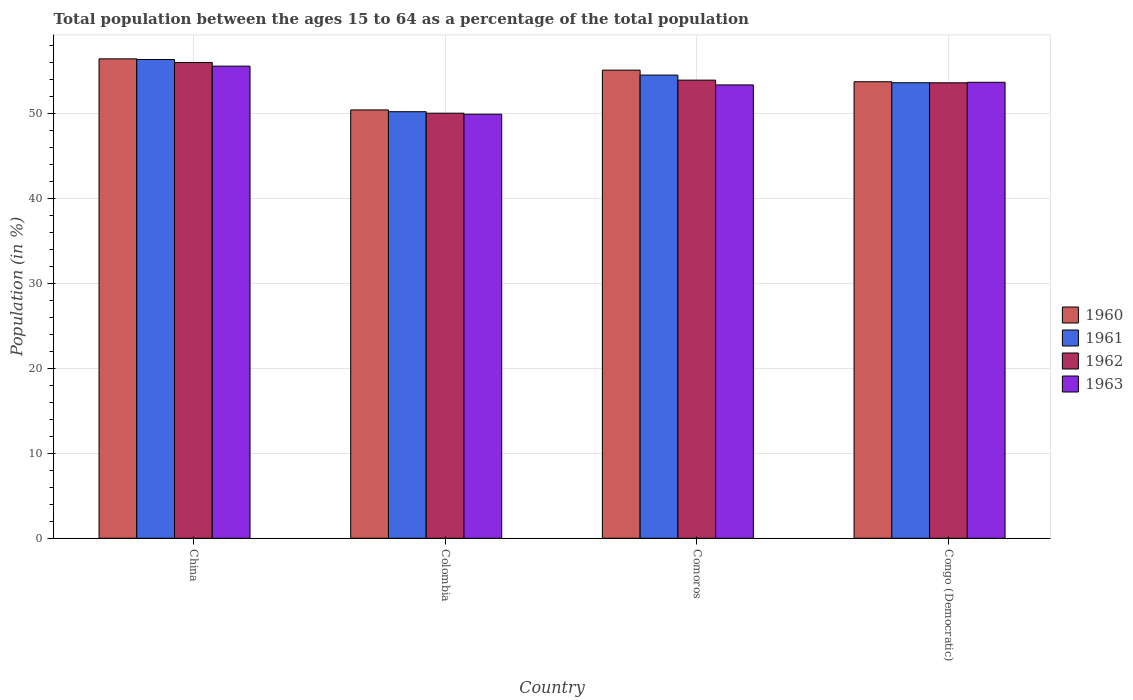How many groups of bars are there?
Your response must be concise. 4. Are the number of bars per tick equal to the number of legend labels?
Ensure brevity in your answer.  Yes. Are the number of bars on each tick of the X-axis equal?
Give a very brief answer. Yes. How many bars are there on the 1st tick from the right?
Make the answer very short. 4. What is the label of the 4th group of bars from the left?
Offer a very short reply. Congo (Democratic). What is the percentage of the population ages 15 to 64 in 1963 in Comoros?
Offer a very short reply. 53.33. Across all countries, what is the maximum percentage of the population ages 15 to 64 in 1960?
Offer a terse response. 56.39. Across all countries, what is the minimum percentage of the population ages 15 to 64 in 1962?
Ensure brevity in your answer.  50. In which country was the percentage of the population ages 15 to 64 in 1962 minimum?
Offer a terse response. Colombia. What is the total percentage of the population ages 15 to 64 in 1962 in the graph?
Your answer should be very brief. 213.43. What is the difference between the percentage of the population ages 15 to 64 in 1962 in Colombia and that in Congo (Democratic)?
Ensure brevity in your answer.  -3.58. What is the difference between the percentage of the population ages 15 to 64 in 1960 in China and the percentage of the population ages 15 to 64 in 1962 in Congo (Democratic)?
Give a very brief answer. 2.82. What is the average percentage of the population ages 15 to 64 in 1963 per country?
Your answer should be compact. 53.1. What is the difference between the percentage of the population ages 15 to 64 of/in 1962 and percentage of the population ages 15 to 64 of/in 1963 in Comoros?
Keep it short and to the point. 0.56. What is the ratio of the percentage of the population ages 15 to 64 in 1962 in China to that in Comoros?
Provide a succinct answer. 1.04. What is the difference between the highest and the second highest percentage of the population ages 15 to 64 in 1963?
Ensure brevity in your answer.  -0.31. What is the difference between the highest and the lowest percentage of the population ages 15 to 64 in 1962?
Your answer should be very brief. 5.96. What does the 1st bar from the left in Comoros represents?
Offer a very short reply. 1960. Is it the case that in every country, the sum of the percentage of the population ages 15 to 64 in 1962 and percentage of the population ages 15 to 64 in 1963 is greater than the percentage of the population ages 15 to 64 in 1960?
Provide a succinct answer. Yes. How many bars are there?
Your response must be concise. 16. How many countries are there in the graph?
Give a very brief answer. 4. What is the difference between two consecutive major ticks on the Y-axis?
Your answer should be very brief. 10. Are the values on the major ticks of Y-axis written in scientific E-notation?
Make the answer very short. No. Does the graph contain grids?
Provide a succinct answer. Yes. How many legend labels are there?
Make the answer very short. 4. What is the title of the graph?
Keep it short and to the point. Total population between the ages 15 to 64 as a percentage of the total population. Does "2009" appear as one of the legend labels in the graph?
Your response must be concise. No. What is the label or title of the Y-axis?
Give a very brief answer. Population (in %). What is the Population (in %) of 1960 in China?
Give a very brief answer. 56.39. What is the Population (in %) in 1961 in China?
Keep it short and to the point. 56.32. What is the Population (in %) in 1962 in China?
Give a very brief answer. 55.96. What is the Population (in %) of 1963 in China?
Provide a short and direct response. 55.54. What is the Population (in %) in 1960 in Colombia?
Your answer should be compact. 50.39. What is the Population (in %) of 1961 in Colombia?
Your response must be concise. 50.18. What is the Population (in %) of 1962 in Colombia?
Give a very brief answer. 50. What is the Population (in %) in 1963 in Colombia?
Ensure brevity in your answer.  49.88. What is the Population (in %) in 1960 in Comoros?
Provide a succinct answer. 55.07. What is the Population (in %) of 1961 in Comoros?
Your answer should be very brief. 54.48. What is the Population (in %) in 1962 in Comoros?
Ensure brevity in your answer.  53.89. What is the Population (in %) of 1963 in Comoros?
Make the answer very short. 53.33. What is the Population (in %) of 1960 in Congo (Democratic)?
Provide a succinct answer. 53.7. What is the Population (in %) of 1961 in Congo (Democratic)?
Your answer should be very brief. 53.59. What is the Population (in %) in 1962 in Congo (Democratic)?
Provide a short and direct response. 53.58. What is the Population (in %) in 1963 in Congo (Democratic)?
Your answer should be compact. 53.64. Across all countries, what is the maximum Population (in %) in 1960?
Provide a short and direct response. 56.39. Across all countries, what is the maximum Population (in %) in 1961?
Provide a short and direct response. 56.32. Across all countries, what is the maximum Population (in %) in 1962?
Provide a succinct answer. 55.96. Across all countries, what is the maximum Population (in %) of 1963?
Make the answer very short. 55.54. Across all countries, what is the minimum Population (in %) of 1960?
Ensure brevity in your answer.  50.39. Across all countries, what is the minimum Population (in %) of 1961?
Give a very brief answer. 50.18. Across all countries, what is the minimum Population (in %) of 1962?
Make the answer very short. 50. Across all countries, what is the minimum Population (in %) in 1963?
Give a very brief answer. 49.88. What is the total Population (in %) of 1960 in the graph?
Offer a very short reply. 215.55. What is the total Population (in %) of 1961 in the graph?
Give a very brief answer. 214.56. What is the total Population (in %) of 1962 in the graph?
Your answer should be very brief. 213.43. What is the total Population (in %) in 1963 in the graph?
Your answer should be compact. 212.38. What is the difference between the Population (in %) in 1960 in China and that in Colombia?
Your response must be concise. 6.01. What is the difference between the Population (in %) in 1961 in China and that in Colombia?
Your response must be concise. 6.14. What is the difference between the Population (in %) in 1962 in China and that in Colombia?
Ensure brevity in your answer.  5.96. What is the difference between the Population (in %) of 1963 in China and that in Colombia?
Your answer should be compact. 5.65. What is the difference between the Population (in %) in 1960 in China and that in Comoros?
Offer a terse response. 1.33. What is the difference between the Population (in %) of 1961 in China and that in Comoros?
Your answer should be very brief. 1.83. What is the difference between the Population (in %) in 1962 in China and that in Comoros?
Make the answer very short. 2.07. What is the difference between the Population (in %) of 1963 in China and that in Comoros?
Provide a short and direct response. 2.21. What is the difference between the Population (in %) of 1960 in China and that in Congo (Democratic)?
Keep it short and to the point. 2.69. What is the difference between the Population (in %) in 1961 in China and that in Congo (Democratic)?
Make the answer very short. 2.73. What is the difference between the Population (in %) in 1962 in China and that in Congo (Democratic)?
Your answer should be compact. 2.38. What is the difference between the Population (in %) of 1963 in China and that in Congo (Democratic)?
Offer a very short reply. 1.9. What is the difference between the Population (in %) of 1960 in Colombia and that in Comoros?
Offer a terse response. -4.68. What is the difference between the Population (in %) of 1961 in Colombia and that in Comoros?
Offer a terse response. -4.31. What is the difference between the Population (in %) of 1962 in Colombia and that in Comoros?
Your answer should be compact. -3.89. What is the difference between the Population (in %) of 1963 in Colombia and that in Comoros?
Provide a succinct answer. -3.45. What is the difference between the Population (in %) of 1960 in Colombia and that in Congo (Democratic)?
Your answer should be compact. -3.32. What is the difference between the Population (in %) of 1961 in Colombia and that in Congo (Democratic)?
Keep it short and to the point. -3.41. What is the difference between the Population (in %) in 1962 in Colombia and that in Congo (Democratic)?
Give a very brief answer. -3.58. What is the difference between the Population (in %) in 1963 in Colombia and that in Congo (Democratic)?
Ensure brevity in your answer.  -3.76. What is the difference between the Population (in %) of 1960 in Comoros and that in Congo (Democratic)?
Provide a short and direct response. 1.36. What is the difference between the Population (in %) in 1961 in Comoros and that in Congo (Democratic)?
Provide a succinct answer. 0.9. What is the difference between the Population (in %) in 1962 in Comoros and that in Congo (Democratic)?
Provide a short and direct response. 0.31. What is the difference between the Population (in %) in 1963 in Comoros and that in Congo (Democratic)?
Keep it short and to the point. -0.31. What is the difference between the Population (in %) of 1960 in China and the Population (in %) of 1961 in Colombia?
Ensure brevity in your answer.  6.22. What is the difference between the Population (in %) in 1960 in China and the Population (in %) in 1962 in Colombia?
Your answer should be compact. 6.39. What is the difference between the Population (in %) in 1960 in China and the Population (in %) in 1963 in Colombia?
Keep it short and to the point. 6.51. What is the difference between the Population (in %) of 1961 in China and the Population (in %) of 1962 in Colombia?
Your response must be concise. 6.31. What is the difference between the Population (in %) of 1961 in China and the Population (in %) of 1963 in Colombia?
Ensure brevity in your answer.  6.44. What is the difference between the Population (in %) in 1962 in China and the Population (in %) in 1963 in Colombia?
Make the answer very short. 6.08. What is the difference between the Population (in %) of 1960 in China and the Population (in %) of 1961 in Comoros?
Make the answer very short. 1.91. What is the difference between the Population (in %) in 1960 in China and the Population (in %) in 1962 in Comoros?
Keep it short and to the point. 2.5. What is the difference between the Population (in %) of 1960 in China and the Population (in %) of 1963 in Comoros?
Give a very brief answer. 3.07. What is the difference between the Population (in %) of 1961 in China and the Population (in %) of 1962 in Comoros?
Offer a very short reply. 2.43. What is the difference between the Population (in %) of 1961 in China and the Population (in %) of 1963 in Comoros?
Provide a short and direct response. 2.99. What is the difference between the Population (in %) in 1962 in China and the Population (in %) in 1963 in Comoros?
Offer a terse response. 2.63. What is the difference between the Population (in %) of 1960 in China and the Population (in %) of 1961 in Congo (Democratic)?
Provide a succinct answer. 2.81. What is the difference between the Population (in %) in 1960 in China and the Population (in %) in 1962 in Congo (Democratic)?
Your answer should be very brief. 2.82. What is the difference between the Population (in %) in 1960 in China and the Population (in %) in 1963 in Congo (Democratic)?
Your answer should be very brief. 2.76. What is the difference between the Population (in %) of 1961 in China and the Population (in %) of 1962 in Congo (Democratic)?
Make the answer very short. 2.74. What is the difference between the Population (in %) of 1961 in China and the Population (in %) of 1963 in Congo (Democratic)?
Keep it short and to the point. 2.68. What is the difference between the Population (in %) of 1962 in China and the Population (in %) of 1963 in Congo (Democratic)?
Your response must be concise. 2.32. What is the difference between the Population (in %) of 1960 in Colombia and the Population (in %) of 1961 in Comoros?
Make the answer very short. -4.1. What is the difference between the Population (in %) of 1960 in Colombia and the Population (in %) of 1962 in Comoros?
Ensure brevity in your answer.  -3.5. What is the difference between the Population (in %) of 1960 in Colombia and the Population (in %) of 1963 in Comoros?
Offer a very short reply. -2.94. What is the difference between the Population (in %) in 1961 in Colombia and the Population (in %) in 1962 in Comoros?
Offer a terse response. -3.71. What is the difference between the Population (in %) of 1961 in Colombia and the Population (in %) of 1963 in Comoros?
Give a very brief answer. -3.15. What is the difference between the Population (in %) in 1962 in Colombia and the Population (in %) in 1963 in Comoros?
Provide a succinct answer. -3.33. What is the difference between the Population (in %) of 1960 in Colombia and the Population (in %) of 1961 in Congo (Democratic)?
Make the answer very short. -3.2. What is the difference between the Population (in %) in 1960 in Colombia and the Population (in %) in 1962 in Congo (Democratic)?
Your response must be concise. -3.19. What is the difference between the Population (in %) in 1960 in Colombia and the Population (in %) in 1963 in Congo (Democratic)?
Provide a short and direct response. -3.25. What is the difference between the Population (in %) of 1961 in Colombia and the Population (in %) of 1962 in Congo (Democratic)?
Give a very brief answer. -3.4. What is the difference between the Population (in %) of 1961 in Colombia and the Population (in %) of 1963 in Congo (Democratic)?
Offer a terse response. -3.46. What is the difference between the Population (in %) in 1962 in Colombia and the Population (in %) in 1963 in Congo (Democratic)?
Your answer should be very brief. -3.63. What is the difference between the Population (in %) in 1960 in Comoros and the Population (in %) in 1961 in Congo (Democratic)?
Provide a short and direct response. 1.48. What is the difference between the Population (in %) of 1960 in Comoros and the Population (in %) of 1962 in Congo (Democratic)?
Provide a succinct answer. 1.49. What is the difference between the Population (in %) in 1960 in Comoros and the Population (in %) in 1963 in Congo (Democratic)?
Offer a terse response. 1.43. What is the difference between the Population (in %) of 1961 in Comoros and the Population (in %) of 1962 in Congo (Democratic)?
Offer a very short reply. 0.91. What is the difference between the Population (in %) of 1961 in Comoros and the Population (in %) of 1963 in Congo (Democratic)?
Provide a succinct answer. 0.85. What is the difference between the Population (in %) in 1962 in Comoros and the Population (in %) in 1963 in Congo (Democratic)?
Your response must be concise. 0.25. What is the average Population (in %) of 1960 per country?
Your answer should be compact. 53.89. What is the average Population (in %) of 1961 per country?
Keep it short and to the point. 53.64. What is the average Population (in %) in 1962 per country?
Your response must be concise. 53.36. What is the average Population (in %) in 1963 per country?
Your response must be concise. 53.1. What is the difference between the Population (in %) of 1960 and Population (in %) of 1961 in China?
Keep it short and to the point. 0.08. What is the difference between the Population (in %) of 1960 and Population (in %) of 1962 in China?
Provide a succinct answer. 0.43. What is the difference between the Population (in %) of 1960 and Population (in %) of 1963 in China?
Your answer should be compact. 0.86. What is the difference between the Population (in %) of 1961 and Population (in %) of 1962 in China?
Your response must be concise. 0.35. What is the difference between the Population (in %) of 1961 and Population (in %) of 1963 in China?
Your answer should be compact. 0.78. What is the difference between the Population (in %) in 1962 and Population (in %) in 1963 in China?
Offer a very short reply. 0.43. What is the difference between the Population (in %) of 1960 and Population (in %) of 1961 in Colombia?
Provide a succinct answer. 0.21. What is the difference between the Population (in %) of 1960 and Population (in %) of 1962 in Colombia?
Your answer should be compact. 0.38. What is the difference between the Population (in %) in 1960 and Population (in %) in 1963 in Colombia?
Your response must be concise. 0.5. What is the difference between the Population (in %) in 1961 and Population (in %) in 1962 in Colombia?
Offer a terse response. 0.17. What is the difference between the Population (in %) in 1961 and Population (in %) in 1963 in Colombia?
Offer a terse response. 0.3. What is the difference between the Population (in %) in 1962 and Population (in %) in 1963 in Colombia?
Offer a very short reply. 0.12. What is the difference between the Population (in %) of 1960 and Population (in %) of 1961 in Comoros?
Offer a terse response. 0.58. What is the difference between the Population (in %) in 1960 and Population (in %) in 1962 in Comoros?
Your answer should be very brief. 1.18. What is the difference between the Population (in %) of 1960 and Population (in %) of 1963 in Comoros?
Ensure brevity in your answer.  1.74. What is the difference between the Population (in %) in 1961 and Population (in %) in 1962 in Comoros?
Provide a short and direct response. 0.59. What is the difference between the Population (in %) in 1961 and Population (in %) in 1963 in Comoros?
Your answer should be compact. 1.15. What is the difference between the Population (in %) in 1962 and Population (in %) in 1963 in Comoros?
Your answer should be compact. 0.56. What is the difference between the Population (in %) of 1960 and Population (in %) of 1961 in Congo (Democratic)?
Keep it short and to the point. 0.12. What is the difference between the Population (in %) in 1960 and Population (in %) in 1962 in Congo (Democratic)?
Your answer should be very brief. 0.12. What is the difference between the Population (in %) in 1960 and Population (in %) in 1963 in Congo (Democratic)?
Offer a very short reply. 0.06. What is the difference between the Population (in %) in 1961 and Population (in %) in 1962 in Congo (Democratic)?
Make the answer very short. 0.01. What is the difference between the Population (in %) in 1961 and Population (in %) in 1963 in Congo (Democratic)?
Make the answer very short. -0.05. What is the difference between the Population (in %) of 1962 and Population (in %) of 1963 in Congo (Democratic)?
Ensure brevity in your answer.  -0.06. What is the ratio of the Population (in %) in 1960 in China to that in Colombia?
Keep it short and to the point. 1.12. What is the ratio of the Population (in %) of 1961 in China to that in Colombia?
Keep it short and to the point. 1.12. What is the ratio of the Population (in %) in 1962 in China to that in Colombia?
Offer a very short reply. 1.12. What is the ratio of the Population (in %) of 1963 in China to that in Colombia?
Ensure brevity in your answer.  1.11. What is the ratio of the Population (in %) of 1960 in China to that in Comoros?
Provide a short and direct response. 1.02. What is the ratio of the Population (in %) of 1961 in China to that in Comoros?
Make the answer very short. 1.03. What is the ratio of the Population (in %) in 1962 in China to that in Comoros?
Your answer should be compact. 1.04. What is the ratio of the Population (in %) in 1963 in China to that in Comoros?
Provide a short and direct response. 1.04. What is the ratio of the Population (in %) in 1960 in China to that in Congo (Democratic)?
Your answer should be very brief. 1.05. What is the ratio of the Population (in %) in 1961 in China to that in Congo (Democratic)?
Make the answer very short. 1.05. What is the ratio of the Population (in %) of 1962 in China to that in Congo (Democratic)?
Give a very brief answer. 1.04. What is the ratio of the Population (in %) of 1963 in China to that in Congo (Democratic)?
Offer a terse response. 1.04. What is the ratio of the Population (in %) of 1960 in Colombia to that in Comoros?
Offer a terse response. 0.92. What is the ratio of the Population (in %) in 1961 in Colombia to that in Comoros?
Provide a short and direct response. 0.92. What is the ratio of the Population (in %) in 1962 in Colombia to that in Comoros?
Your response must be concise. 0.93. What is the ratio of the Population (in %) of 1963 in Colombia to that in Comoros?
Your answer should be very brief. 0.94. What is the ratio of the Population (in %) in 1960 in Colombia to that in Congo (Democratic)?
Give a very brief answer. 0.94. What is the ratio of the Population (in %) of 1961 in Colombia to that in Congo (Democratic)?
Offer a terse response. 0.94. What is the ratio of the Population (in %) in 1962 in Colombia to that in Congo (Democratic)?
Keep it short and to the point. 0.93. What is the ratio of the Population (in %) in 1960 in Comoros to that in Congo (Democratic)?
Provide a short and direct response. 1.03. What is the ratio of the Population (in %) in 1961 in Comoros to that in Congo (Democratic)?
Make the answer very short. 1.02. What is the ratio of the Population (in %) of 1962 in Comoros to that in Congo (Democratic)?
Provide a succinct answer. 1.01. What is the ratio of the Population (in %) in 1963 in Comoros to that in Congo (Democratic)?
Provide a short and direct response. 0.99. What is the difference between the highest and the second highest Population (in %) in 1960?
Provide a short and direct response. 1.33. What is the difference between the highest and the second highest Population (in %) of 1961?
Ensure brevity in your answer.  1.83. What is the difference between the highest and the second highest Population (in %) in 1962?
Your answer should be compact. 2.07. What is the difference between the highest and the second highest Population (in %) in 1963?
Make the answer very short. 1.9. What is the difference between the highest and the lowest Population (in %) in 1960?
Provide a short and direct response. 6.01. What is the difference between the highest and the lowest Population (in %) of 1961?
Make the answer very short. 6.14. What is the difference between the highest and the lowest Population (in %) in 1962?
Provide a succinct answer. 5.96. What is the difference between the highest and the lowest Population (in %) in 1963?
Give a very brief answer. 5.65. 